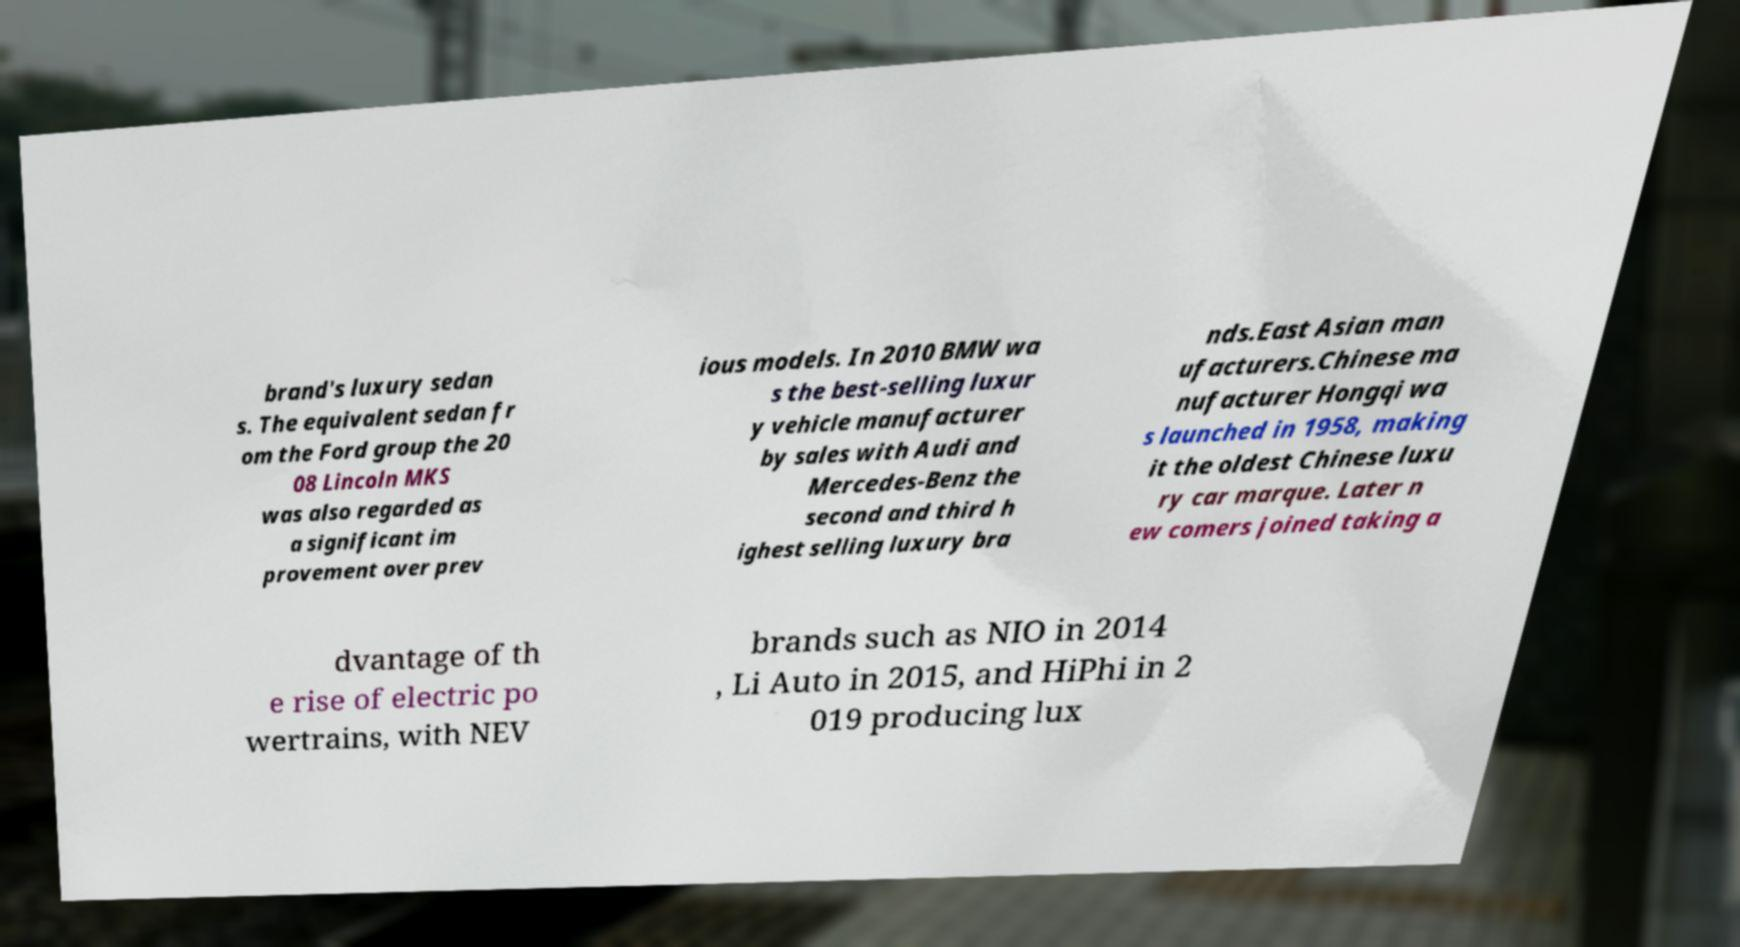There's text embedded in this image that I need extracted. Can you transcribe it verbatim? brand's luxury sedan s. The equivalent sedan fr om the Ford group the 20 08 Lincoln MKS was also regarded as a significant im provement over prev ious models. In 2010 BMW wa s the best-selling luxur y vehicle manufacturer by sales with Audi and Mercedes-Benz the second and third h ighest selling luxury bra nds.East Asian man ufacturers.Chinese ma nufacturer Hongqi wa s launched in 1958, making it the oldest Chinese luxu ry car marque. Later n ew comers joined taking a dvantage of th e rise of electric po wertrains, with NEV brands such as NIO in 2014 , Li Auto in 2015, and HiPhi in 2 019 producing lux 